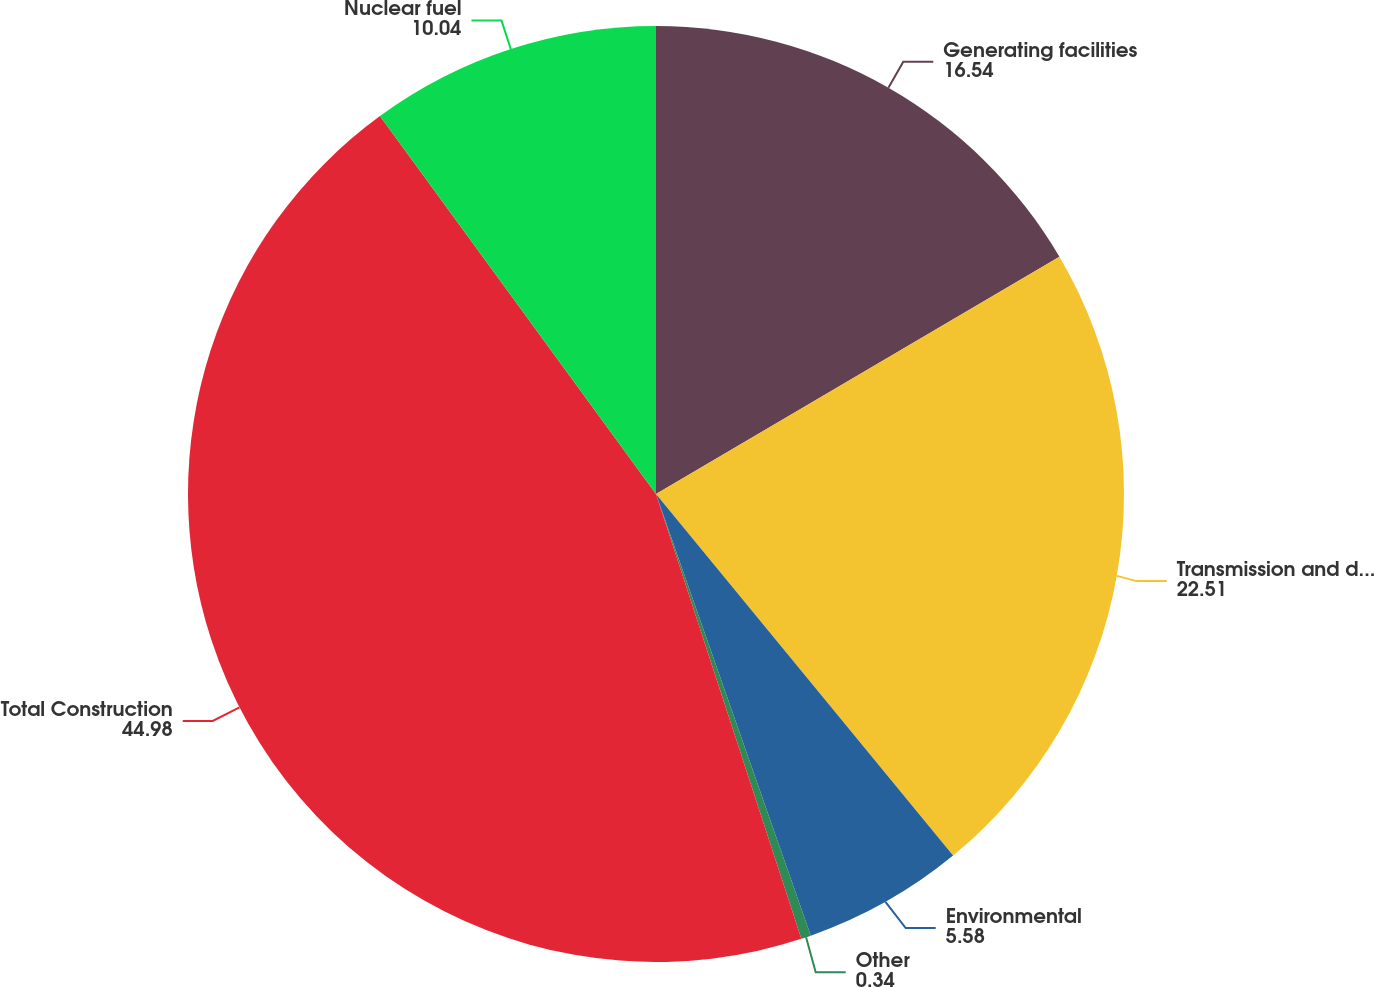Convert chart. <chart><loc_0><loc_0><loc_500><loc_500><pie_chart><fcel>Generating facilities<fcel>Transmission and distribution<fcel>Environmental<fcel>Other<fcel>Total Construction<fcel>Nuclear fuel<nl><fcel>16.54%<fcel>22.51%<fcel>5.58%<fcel>0.34%<fcel>44.98%<fcel>10.04%<nl></chart> 